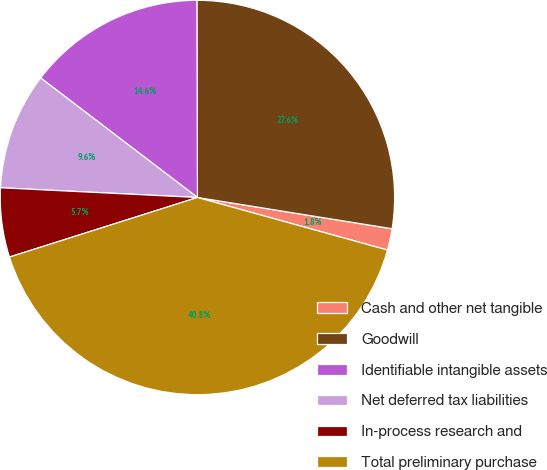Convert chart to OTSL. <chart><loc_0><loc_0><loc_500><loc_500><pie_chart><fcel>Cash and other net tangible<fcel>Goodwill<fcel>Identifiable intangible assets<fcel>Net deferred tax liabilities<fcel>In-process research and<fcel>Total preliminary purchase<nl><fcel>1.76%<fcel>27.58%<fcel>14.59%<fcel>9.58%<fcel>5.67%<fcel>40.82%<nl></chart> 